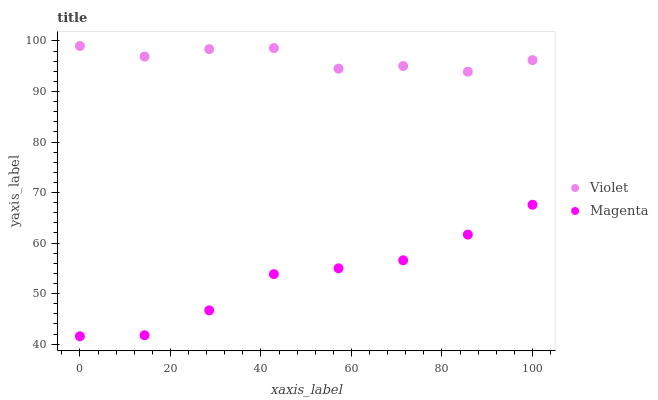Does Magenta have the minimum area under the curve?
Answer yes or no. Yes. Does Violet have the maximum area under the curve?
Answer yes or no. Yes. Does Violet have the minimum area under the curve?
Answer yes or no. No. Is Magenta the smoothest?
Answer yes or no. Yes. Is Violet the roughest?
Answer yes or no. Yes. Is Violet the smoothest?
Answer yes or no. No. Does Magenta have the lowest value?
Answer yes or no. Yes. Does Violet have the lowest value?
Answer yes or no. No. Does Violet have the highest value?
Answer yes or no. Yes. Is Magenta less than Violet?
Answer yes or no. Yes. Is Violet greater than Magenta?
Answer yes or no. Yes. Does Magenta intersect Violet?
Answer yes or no. No. 